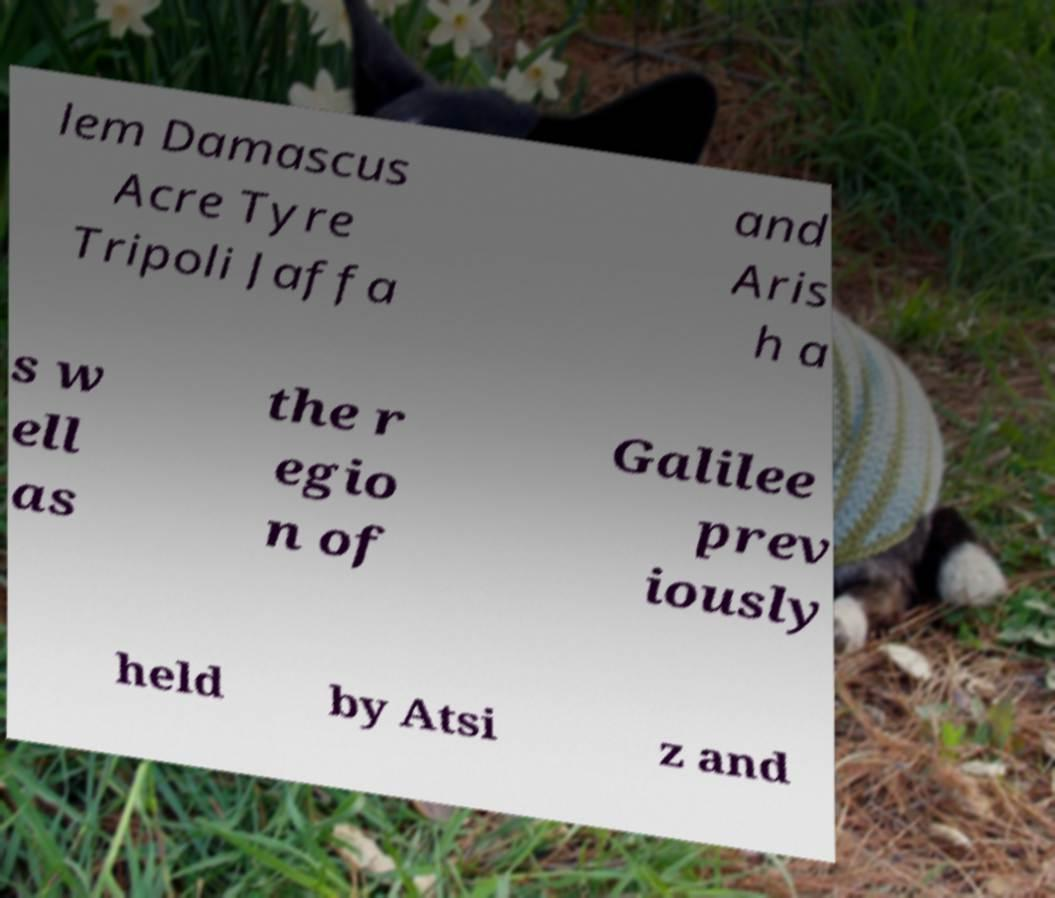Can you accurately transcribe the text from the provided image for me? lem Damascus Acre Tyre Tripoli Jaffa and Aris h a s w ell as the r egio n of Galilee prev iously held by Atsi z and 